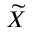Convert formula to latex. <formula><loc_0><loc_0><loc_500><loc_500>\widetilde { X }</formula> 